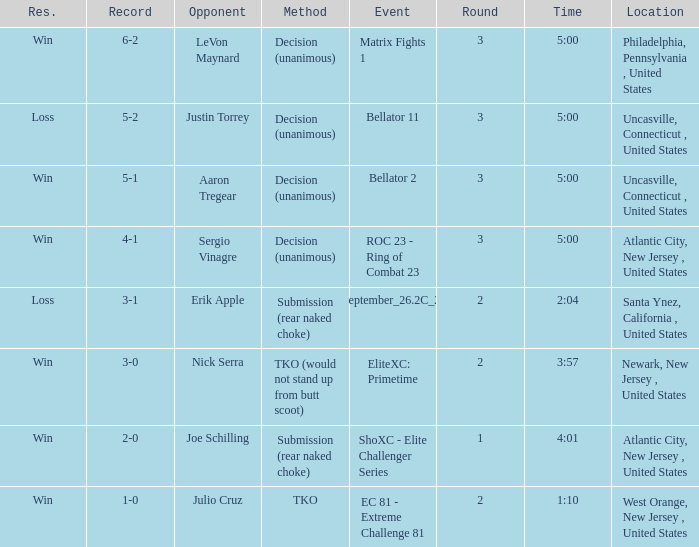Could you parse the entire table? {'header': ['Res.', 'Record', 'Opponent', 'Method', 'Event', 'Round', 'Time', 'Location'], 'rows': [['Win', '6-2', 'LeVon Maynard', 'Decision (unanimous)', 'Matrix Fights 1', '3', '5:00', 'Philadelphia, Pennsylvania , United States'], ['Loss', '5-2', 'Justin Torrey', 'Decision (unanimous)', 'Bellator 11', '3', '5:00', 'Uncasville, Connecticut , United States'], ['Win', '5-1', 'Aaron Tregear', 'Decision (unanimous)', 'Bellator 2', '3', '5:00', 'Uncasville, Connecticut , United States'], ['Win', '4-1', 'Sergio Vinagre', 'Decision (unanimous)', 'ROC 23 - Ring of Combat 23', '3', '5:00', 'Atlantic City, New Jersey , United States'], ['Loss', '3-1', 'Erik Apple', 'Submission (rear naked choke)', 'ShoXC#September_26.2C_2008_card', '2', '2:04', 'Santa Ynez, California , United States'], ['Win', '3-0', 'Nick Serra', 'TKO (would not stand up from butt scoot)', 'EliteXC: Primetime', '2', '3:57', 'Newark, New Jersey , United States'], ['Win', '2-0', 'Joe Schilling', 'Submission (rear naked choke)', 'ShoXC - Elite Challenger Series', '1', '4:01', 'Atlantic City, New Jersey , United States'], ['Win', '1-0', 'Julio Cruz', 'TKO', 'EC 81 - Extreme Challenge 81', '2', '1:10', 'West Orange, New Jersey , United States']]} In which round did the method result in a tko (unable to rise from butt scoot)? 2.0. 